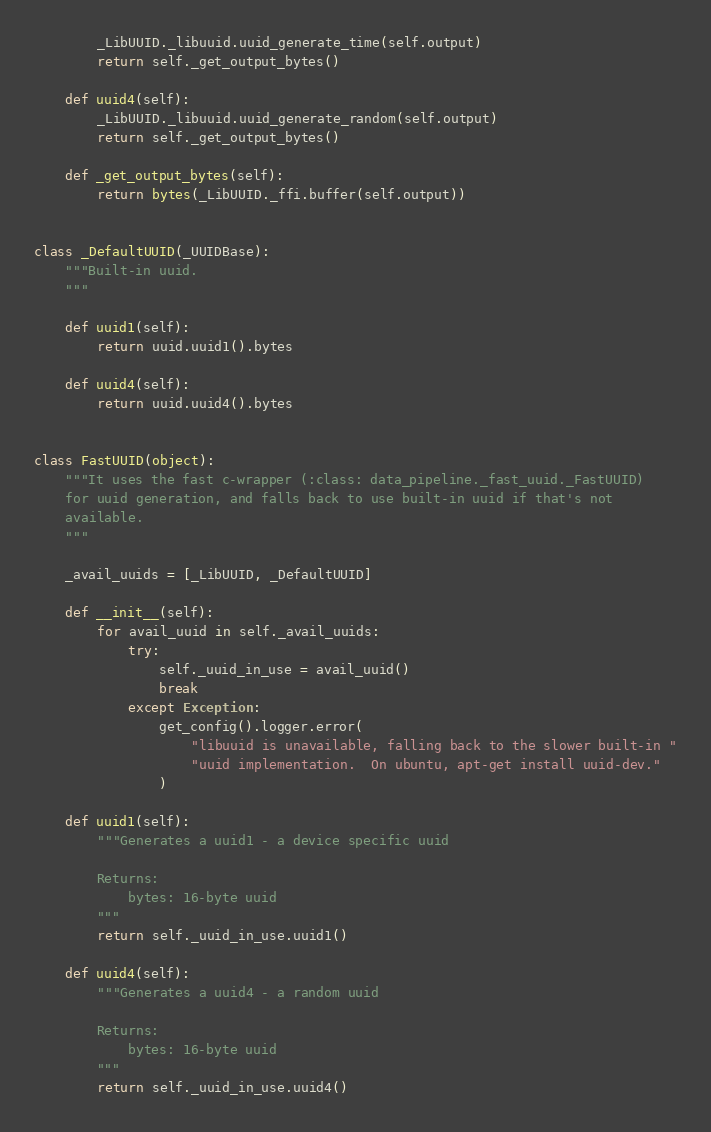<code> <loc_0><loc_0><loc_500><loc_500><_Python_>        _LibUUID._libuuid.uuid_generate_time(self.output)
        return self._get_output_bytes()

    def uuid4(self):
        _LibUUID._libuuid.uuid_generate_random(self.output)
        return self._get_output_bytes()

    def _get_output_bytes(self):
        return bytes(_LibUUID._ffi.buffer(self.output))


class _DefaultUUID(_UUIDBase):
    """Built-in uuid.
    """

    def uuid1(self):
        return uuid.uuid1().bytes

    def uuid4(self):
        return uuid.uuid4().bytes


class FastUUID(object):
    """It uses the fast c-wrapper (:class: data_pipeline._fast_uuid._FastUUID)
    for uuid generation, and falls back to use built-in uuid if that's not
    available.
    """

    _avail_uuids = [_LibUUID, _DefaultUUID]

    def __init__(self):
        for avail_uuid in self._avail_uuids:
            try:
                self._uuid_in_use = avail_uuid()
                break
            except Exception:
                get_config().logger.error(
                    "libuuid is unavailable, falling back to the slower built-in "
                    "uuid implementation.  On ubuntu, apt-get install uuid-dev."
                )

    def uuid1(self):
        """Generates a uuid1 - a device specific uuid

        Returns:
            bytes: 16-byte uuid
        """
        return self._uuid_in_use.uuid1()

    def uuid4(self):
        """Generates a uuid4 - a random uuid

        Returns:
            bytes: 16-byte uuid
        """
        return self._uuid_in_use.uuid4()
</code> 